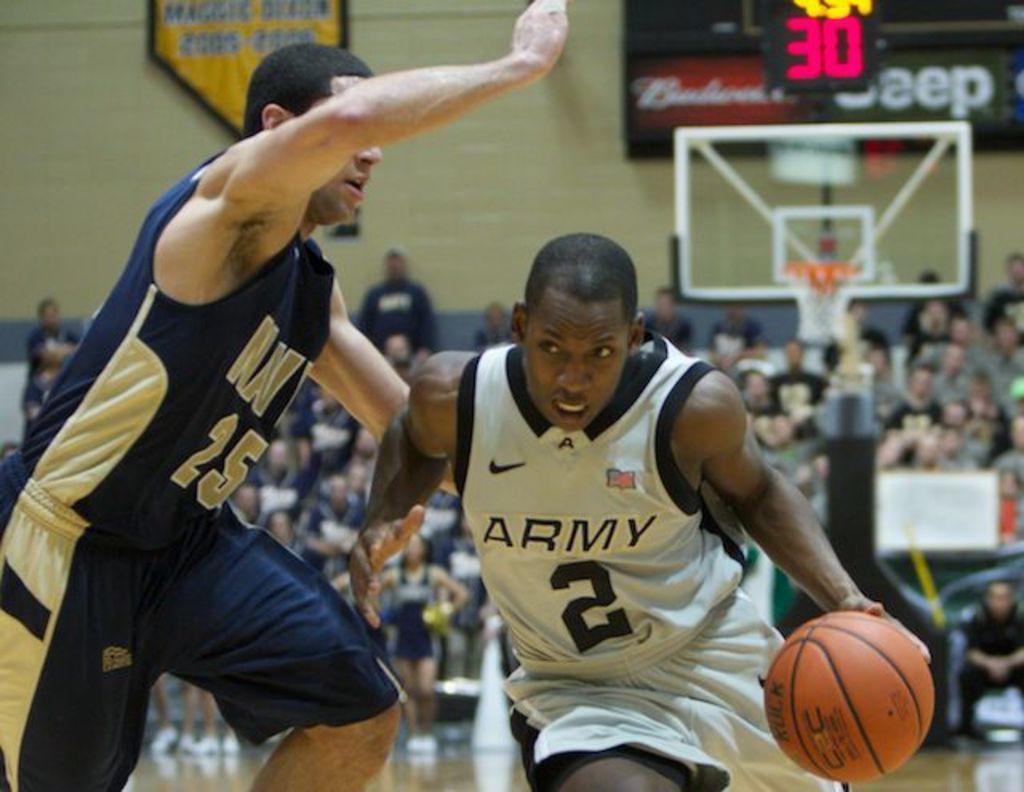Could you give a brief overview of what you see in this image? In this image two people are running. Right side person is holding a ball. Behind him there is a basket attached to a pole. Background there are people. Behind them there is a wall having a screen and a banner. On the screen there is some text displayed. 